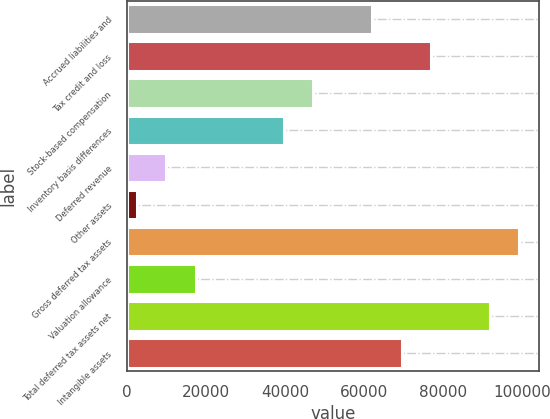<chart> <loc_0><loc_0><loc_500><loc_500><bar_chart><fcel>Accrued liabilities and<fcel>Tax credit and loss<fcel>Stock-based compensation<fcel>Inventory basis differences<fcel>Deferred revenue<fcel>Other assets<fcel>Gross deferred tax assets<fcel>Valuation allowance<fcel>Total deferred tax assets net<fcel>Intangible assets<nl><fcel>62051.8<fcel>76933<fcel>47170.6<fcel>39730<fcel>9967.6<fcel>2527<fcel>99254.8<fcel>17408.2<fcel>91814.2<fcel>69492.4<nl></chart> 